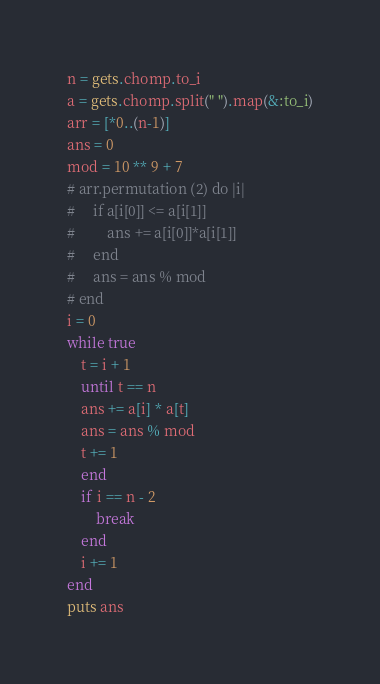Convert code to text. <code><loc_0><loc_0><loc_500><loc_500><_Ruby_>n = gets.chomp.to_i
a = gets.chomp.split(" ").map(&:to_i)
arr = [*0..(n-1)]
ans = 0
mod = 10 ** 9 + 7
# arr.permutation (2) do |i|
#     if a[i[0]] <= a[i[1]]
#         ans += a[i[0]]*a[i[1]]
#     end
#     ans = ans % mod
# end
i = 0
while true
    t = i + 1
    until t == n 
    ans += a[i] * a[t]
    ans = ans % mod
    t += 1
    end
    if i == n - 2
        break
    end
    i += 1
end
puts ans</code> 